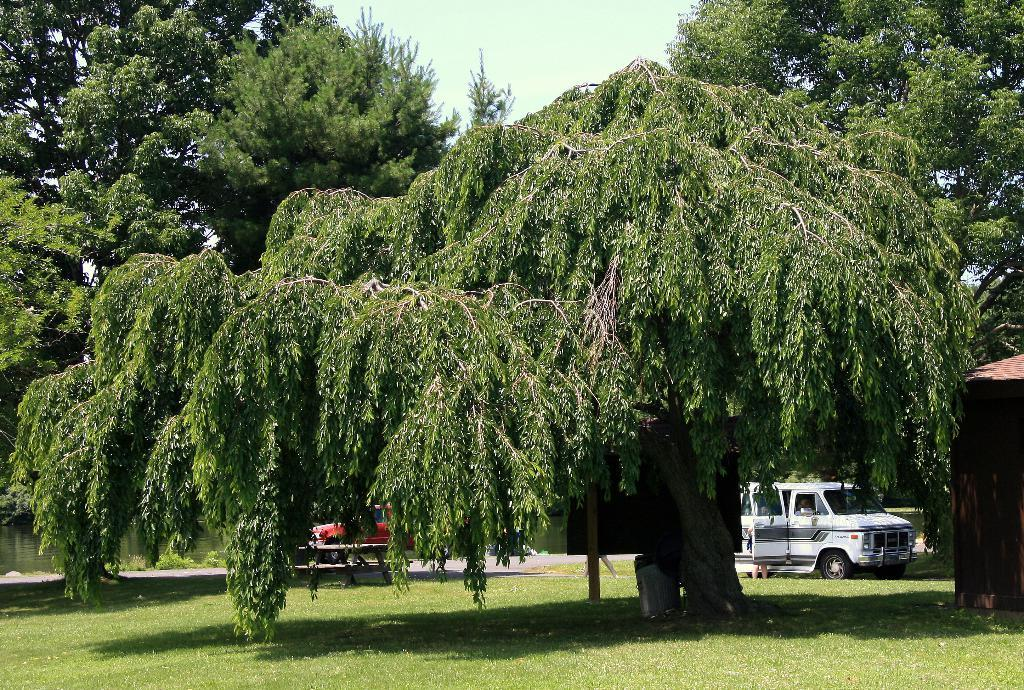What can be seen in the sky in the image? The sky is visible in the image. What type of vegetation is present in the image? There are trees in the image. What mode of transportation can be seen in the image? Vehicles are present in the image. What natural element is visible in the image? There is water visible in the image. What type of ground cover is present in the image? Grass is present in the image. Can you describe any other objects in the image? There are a few other objects in the image. What type of fork can be seen in the image? There is no fork present in the image. What type of crime is being committed in the image? There is no crime being committed in the image. 